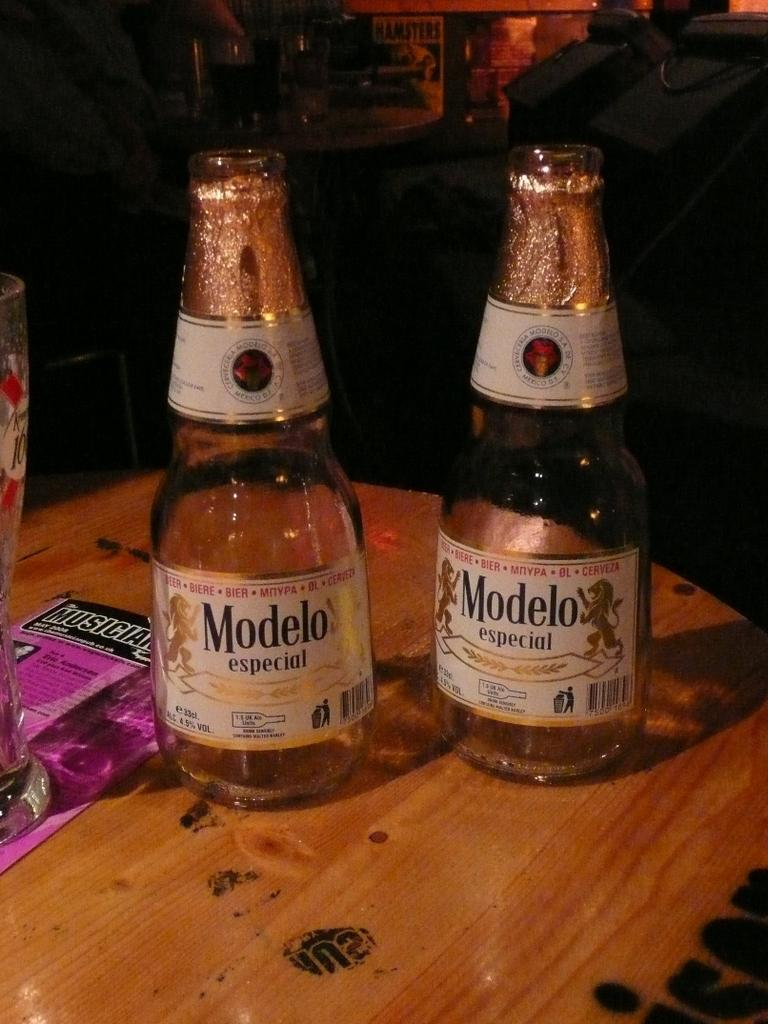What objects are on the table in the image? There are two bottles on a table in the image. Can you describe anything visible in the background of the image? Yes, there are glasses in the background of the image. What type of leather is covering the grapes in the image? There are no grapes or leather present in the image. 